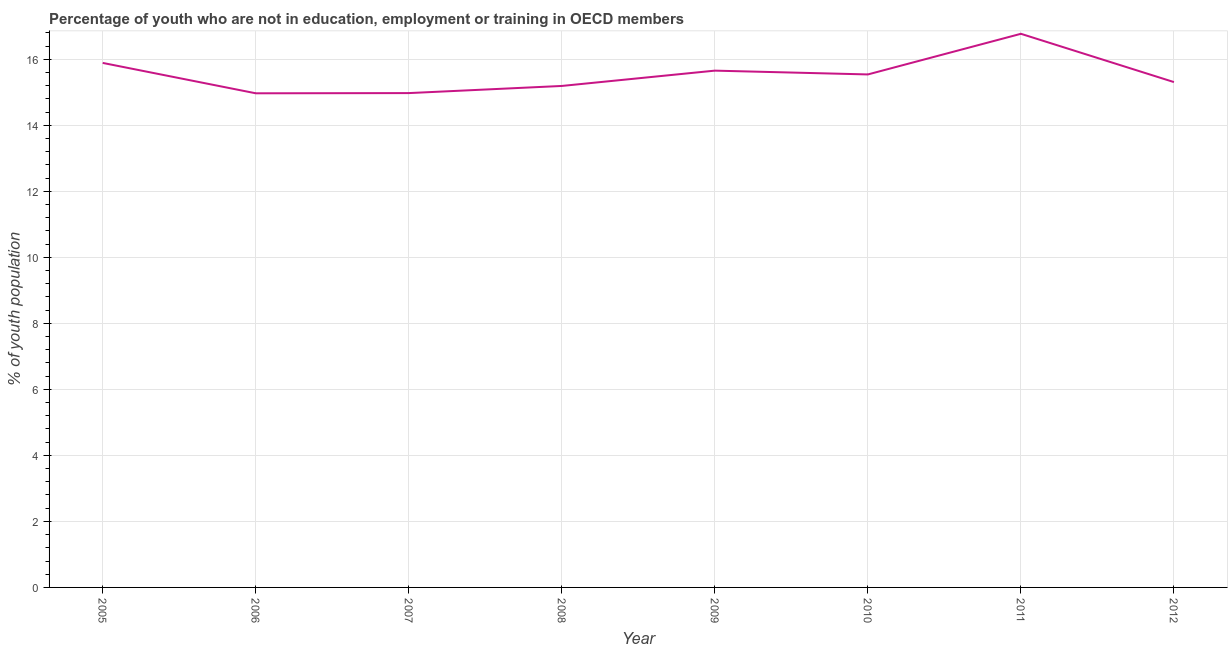What is the unemployed youth population in 2006?
Keep it short and to the point. 14.97. Across all years, what is the maximum unemployed youth population?
Provide a short and direct response. 16.77. Across all years, what is the minimum unemployed youth population?
Your answer should be compact. 14.97. In which year was the unemployed youth population minimum?
Make the answer very short. 2006. What is the sum of the unemployed youth population?
Your answer should be compact. 124.3. What is the difference between the unemployed youth population in 2007 and 2009?
Offer a very short reply. -0.68. What is the average unemployed youth population per year?
Provide a succinct answer. 15.54. What is the median unemployed youth population?
Your answer should be compact. 15.42. In how many years, is the unemployed youth population greater than 12.4 %?
Give a very brief answer. 8. Do a majority of the years between 2009 and 2005 (inclusive) have unemployed youth population greater than 15.2 %?
Your response must be concise. Yes. What is the ratio of the unemployed youth population in 2007 to that in 2008?
Provide a succinct answer. 0.99. Is the difference between the unemployed youth population in 2007 and 2010 greater than the difference between any two years?
Keep it short and to the point. No. What is the difference between the highest and the second highest unemployed youth population?
Offer a terse response. 0.88. Is the sum of the unemployed youth population in 2006 and 2012 greater than the maximum unemployed youth population across all years?
Offer a very short reply. Yes. What is the difference between the highest and the lowest unemployed youth population?
Provide a short and direct response. 1.8. In how many years, is the unemployed youth population greater than the average unemployed youth population taken over all years?
Give a very brief answer. 4. Does the unemployed youth population monotonically increase over the years?
Offer a terse response. No. How many lines are there?
Provide a short and direct response. 1. How many years are there in the graph?
Offer a very short reply. 8. Are the values on the major ticks of Y-axis written in scientific E-notation?
Ensure brevity in your answer.  No. Does the graph contain any zero values?
Provide a succinct answer. No. What is the title of the graph?
Keep it short and to the point. Percentage of youth who are not in education, employment or training in OECD members. What is the label or title of the X-axis?
Provide a succinct answer. Year. What is the label or title of the Y-axis?
Offer a terse response. % of youth population. What is the % of youth population in 2005?
Provide a short and direct response. 15.89. What is the % of youth population of 2006?
Give a very brief answer. 14.97. What is the % of youth population of 2007?
Ensure brevity in your answer.  14.98. What is the % of youth population of 2008?
Your answer should be very brief. 15.19. What is the % of youth population in 2009?
Keep it short and to the point. 15.66. What is the % of youth population in 2010?
Give a very brief answer. 15.54. What is the % of youth population of 2011?
Your answer should be compact. 16.77. What is the % of youth population in 2012?
Your answer should be very brief. 15.31. What is the difference between the % of youth population in 2005 and 2006?
Offer a very short reply. 0.92. What is the difference between the % of youth population in 2005 and 2007?
Give a very brief answer. 0.91. What is the difference between the % of youth population in 2005 and 2008?
Provide a succinct answer. 0.7. What is the difference between the % of youth population in 2005 and 2009?
Offer a very short reply. 0.23. What is the difference between the % of youth population in 2005 and 2010?
Keep it short and to the point. 0.35. What is the difference between the % of youth population in 2005 and 2011?
Make the answer very short. -0.88. What is the difference between the % of youth population in 2005 and 2012?
Offer a very short reply. 0.58. What is the difference between the % of youth population in 2006 and 2007?
Provide a succinct answer. -0.01. What is the difference between the % of youth population in 2006 and 2008?
Offer a terse response. -0.22. What is the difference between the % of youth population in 2006 and 2009?
Provide a succinct answer. -0.69. What is the difference between the % of youth population in 2006 and 2010?
Make the answer very short. -0.57. What is the difference between the % of youth population in 2006 and 2011?
Your answer should be very brief. -1.8. What is the difference between the % of youth population in 2006 and 2012?
Give a very brief answer. -0.34. What is the difference between the % of youth population in 2007 and 2008?
Provide a short and direct response. -0.22. What is the difference between the % of youth population in 2007 and 2009?
Give a very brief answer. -0.68. What is the difference between the % of youth population in 2007 and 2010?
Make the answer very short. -0.56. What is the difference between the % of youth population in 2007 and 2011?
Give a very brief answer. -1.8. What is the difference between the % of youth population in 2007 and 2012?
Your answer should be compact. -0.33. What is the difference between the % of youth population in 2008 and 2009?
Your response must be concise. -0.46. What is the difference between the % of youth population in 2008 and 2010?
Keep it short and to the point. -0.35. What is the difference between the % of youth population in 2008 and 2011?
Offer a terse response. -1.58. What is the difference between the % of youth population in 2008 and 2012?
Provide a succinct answer. -0.12. What is the difference between the % of youth population in 2009 and 2010?
Provide a succinct answer. 0.12. What is the difference between the % of youth population in 2009 and 2011?
Your response must be concise. -1.12. What is the difference between the % of youth population in 2009 and 2012?
Your response must be concise. 0.35. What is the difference between the % of youth population in 2010 and 2011?
Keep it short and to the point. -1.23. What is the difference between the % of youth population in 2010 and 2012?
Make the answer very short. 0.23. What is the difference between the % of youth population in 2011 and 2012?
Offer a very short reply. 1.46. What is the ratio of the % of youth population in 2005 to that in 2006?
Provide a short and direct response. 1.06. What is the ratio of the % of youth population in 2005 to that in 2007?
Your answer should be compact. 1.06. What is the ratio of the % of youth population in 2005 to that in 2008?
Make the answer very short. 1.05. What is the ratio of the % of youth population in 2005 to that in 2009?
Provide a succinct answer. 1.01. What is the ratio of the % of youth population in 2005 to that in 2010?
Your answer should be very brief. 1.02. What is the ratio of the % of youth population in 2005 to that in 2011?
Give a very brief answer. 0.95. What is the ratio of the % of youth population in 2005 to that in 2012?
Your response must be concise. 1.04. What is the ratio of the % of youth population in 2006 to that in 2008?
Provide a short and direct response. 0.98. What is the ratio of the % of youth population in 2006 to that in 2009?
Provide a succinct answer. 0.96. What is the ratio of the % of youth population in 2006 to that in 2011?
Your answer should be very brief. 0.89. What is the ratio of the % of youth population in 2006 to that in 2012?
Your answer should be compact. 0.98. What is the ratio of the % of youth population in 2007 to that in 2009?
Provide a short and direct response. 0.96. What is the ratio of the % of youth population in 2007 to that in 2011?
Your answer should be compact. 0.89. What is the ratio of the % of youth population in 2007 to that in 2012?
Your response must be concise. 0.98. What is the ratio of the % of youth population in 2008 to that in 2010?
Offer a terse response. 0.98. What is the ratio of the % of youth population in 2008 to that in 2011?
Keep it short and to the point. 0.91. What is the ratio of the % of youth population in 2009 to that in 2010?
Keep it short and to the point. 1.01. What is the ratio of the % of youth population in 2009 to that in 2011?
Ensure brevity in your answer.  0.93. What is the ratio of the % of youth population in 2009 to that in 2012?
Make the answer very short. 1.02. What is the ratio of the % of youth population in 2010 to that in 2011?
Your response must be concise. 0.93. What is the ratio of the % of youth population in 2010 to that in 2012?
Provide a short and direct response. 1.01. What is the ratio of the % of youth population in 2011 to that in 2012?
Ensure brevity in your answer.  1.1. 